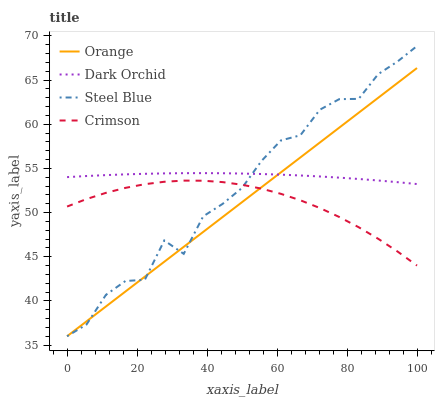Does Orange have the minimum area under the curve?
Answer yes or no. Yes. Does Dark Orchid have the maximum area under the curve?
Answer yes or no. Yes. Does Crimson have the minimum area under the curve?
Answer yes or no. No. Does Crimson have the maximum area under the curve?
Answer yes or no. No. Is Orange the smoothest?
Answer yes or no. Yes. Is Steel Blue the roughest?
Answer yes or no. Yes. Is Crimson the smoothest?
Answer yes or no. No. Is Crimson the roughest?
Answer yes or no. No. Does Orange have the lowest value?
Answer yes or no. Yes. Does Crimson have the lowest value?
Answer yes or no. No. Does Steel Blue have the highest value?
Answer yes or no. Yes. Does Crimson have the highest value?
Answer yes or no. No. Is Crimson less than Dark Orchid?
Answer yes or no. Yes. Is Dark Orchid greater than Crimson?
Answer yes or no. Yes. Does Orange intersect Dark Orchid?
Answer yes or no. Yes. Is Orange less than Dark Orchid?
Answer yes or no. No. Is Orange greater than Dark Orchid?
Answer yes or no. No. Does Crimson intersect Dark Orchid?
Answer yes or no. No. 